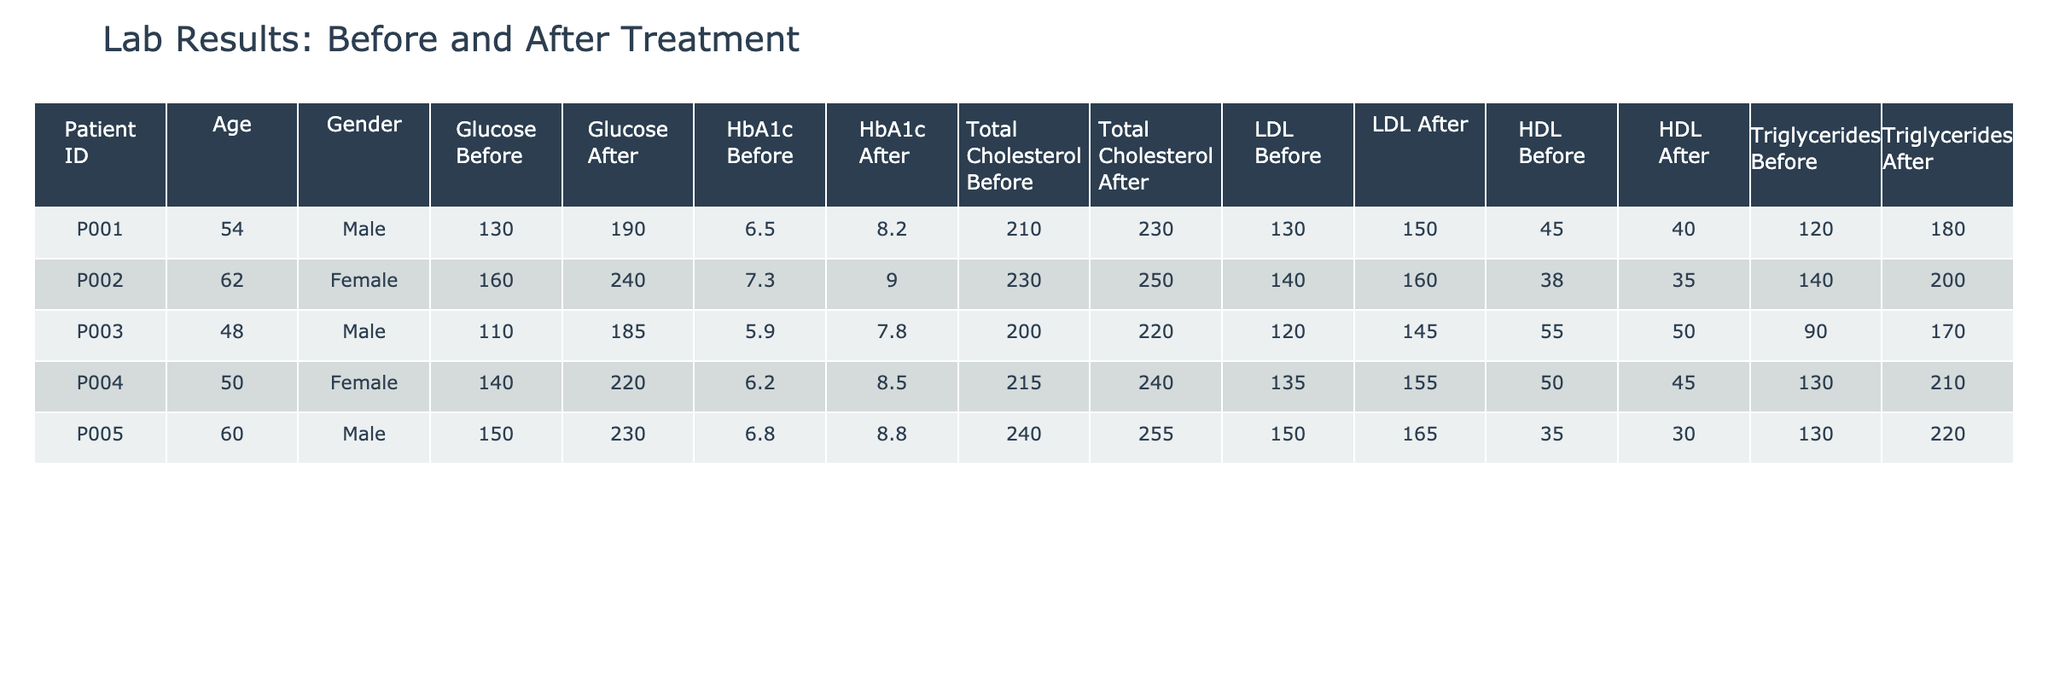What was the glucose level of patient P001 before treatment? In the table, I can find the row for patient P001 under the "Before" treatment phase. The glucose level for this patient is listed as 190 mg/dl.
Answer: 190 mg/dl How much did patient P002's HbA1c percentage decrease after treatment? To find the decrease, I look at the HbA1c percentage for patient P002 before treatment (9.0%) and after treatment (7.3%). The decrease is calculated as 9.0% - 7.3% = 1.7%.
Answer: 1.7% Is the total cholesterol level lower after treatment for patient P005? I can compare the total cholesterol levels for patient P005 before (255 mg/dl) and after treatment (240 mg/dl). Since 240 is less than 255, the total cholesterol level is indeed lower after treatment.
Answer: Yes What is the average glucose level across all patients after treatment? To find the average glucose level after treatment, I add the glucose levels for all patients: (130 + 160 + 110 + 140 + 150) = 690 mg/dl. There are 5 patients, so the average glucose level after treatment is 690/5 = 138 mg/dl.
Answer: 138 mg/dl Did patient P004 experience an increase in HDL cholesterol after treatment? For patient P004, the HDL cholesterol before treatment is 40 mg/dl and after treatment is 50 mg/dl. Since 50 is greater than 40, there was indeed an increase in HDL cholesterol after treatment.
Answer: Yes What was the change in triglycerides for patient P003 from before to after treatment? Looking at patient P003's triglycerides levels, the before level is 170 mg/dl and the after level is 90 mg/dl. The change is calculated as 170 - 90 = 80 mg/dl (a decrease).
Answer: 80 mg/dl decrease Which patient had the highest HbA1c percentage before treatment? Checking the HbA1c percentages before treatment, patient P002 has the highest at 9.0%. No other patient exceeds this value in the before phase.
Answer: P002 How many patients showed an improvement in their total cholesterol after treatment? I will check each patient's total cholesterol levels before and after treatment. Only patient P005 with before 255 mg/dl and after 240 mg/dl, and patient P004 with before 240 mg/dl and after 215 mg/dl have lower after treatment. This means there are 2 patients with improvement.
Answer: 2 